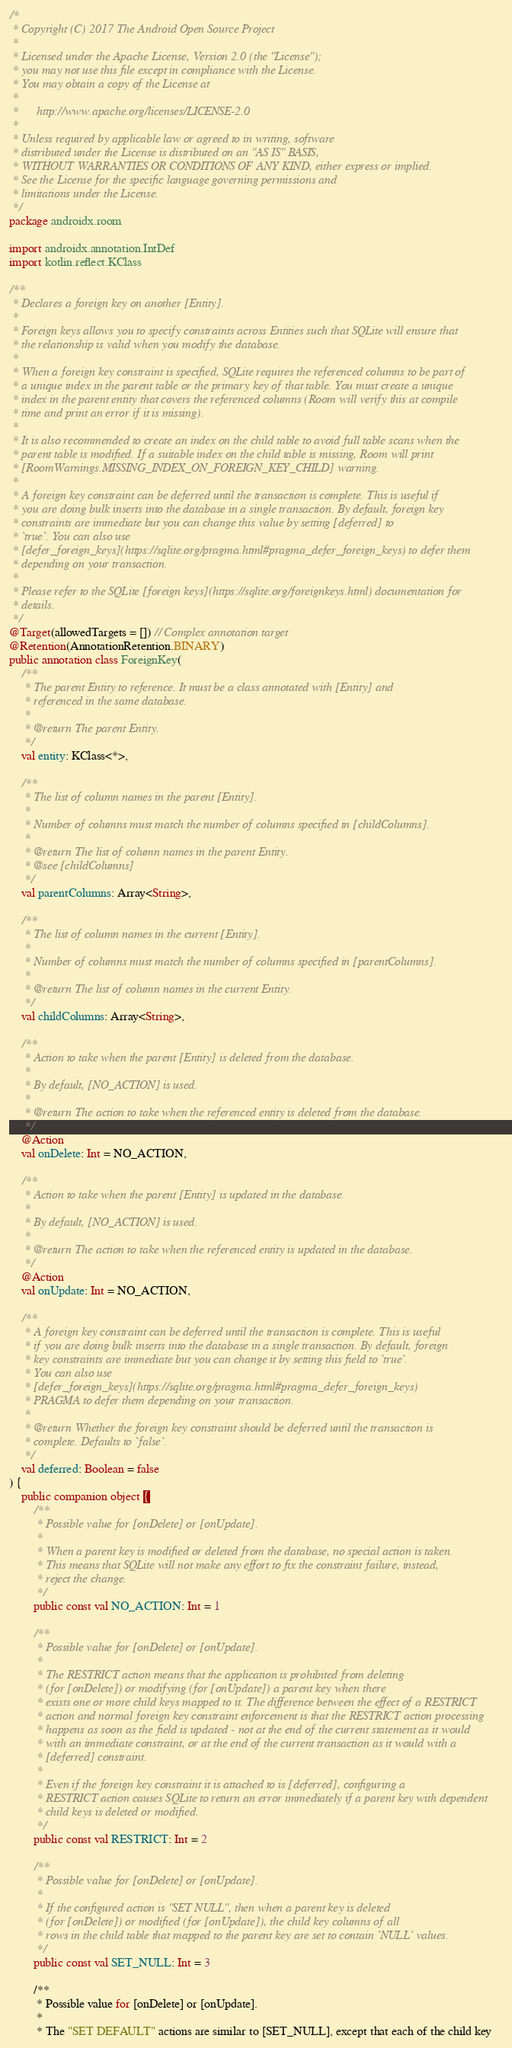Convert code to text. <code><loc_0><loc_0><loc_500><loc_500><_Kotlin_>/*
 * Copyright (C) 2017 The Android Open Source Project
 *
 * Licensed under the Apache License, Version 2.0 (the "License");
 * you may not use this file except in compliance with the License.
 * You may obtain a copy of the License at
 *
 *      http://www.apache.org/licenses/LICENSE-2.0
 *
 * Unless required by applicable law or agreed to in writing, software
 * distributed under the License is distributed on an "AS IS" BASIS,
 * WITHOUT WARRANTIES OR CONDITIONS OF ANY KIND, either express or implied.
 * See the License for the specific language governing permissions and
 * limitations under the License.
 */
package androidx.room

import androidx.annotation.IntDef
import kotlin.reflect.KClass

/**
 * Declares a foreign key on another [Entity].
 *
 * Foreign keys allows you to specify constraints across Entities such that SQLite will ensure that
 * the relationship is valid when you modify the database.
 *
 * When a foreign key constraint is specified, SQLite requires the referenced columns to be part of
 * a unique index in the parent table or the primary key of that table. You must create a unique
 * index in the parent entity that covers the referenced columns (Room will verify this at compile
 * time and print an error if it is missing).
 *
 * It is also recommended to create an index on the child table to avoid full table scans when the
 * parent table is modified. If a suitable index on the child table is missing, Room will print
 * [RoomWarnings.MISSING_INDEX_ON_FOREIGN_KEY_CHILD] warning.
 *
 * A foreign key constraint can be deferred until the transaction is complete. This is useful if
 * you are doing bulk inserts into the database in a single transaction. By default, foreign key
 * constraints are immediate but you can change this value by setting [deferred] to
 * `true`. You can also use
 * [defer_foreign_keys](https://sqlite.org/pragma.html#pragma_defer_foreign_keys) to defer them
 * depending on your transaction.
 *
 * Please refer to the SQLite [foreign keys](https://sqlite.org/foreignkeys.html) documentation for
 * details.
 */
@Target(allowedTargets = []) // Complex annotation target
@Retention(AnnotationRetention.BINARY)
public annotation class ForeignKey(
    /**
     * The parent Entity to reference. It must be a class annotated with [Entity] and
     * referenced in the same database.
     *
     * @return The parent Entity.
     */
    val entity: KClass<*>,

    /**
     * The list of column names in the parent [Entity].
     *
     * Number of columns must match the number of columns specified in [childColumns].
     *
     * @return The list of column names in the parent Entity.
     * @see [childColumns]
     */
    val parentColumns: Array<String>,

    /**
     * The list of column names in the current [Entity].
     *
     * Number of columns must match the number of columns specified in [parentColumns].
     *
     * @return The list of column names in the current Entity.
     */
    val childColumns: Array<String>,

    /**
     * Action to take when the parent [Entity] is deleted from the database.
     *
     * By default, [NO_ACTION] is used.
     *
     * @return The action to take when the referenced entity is deleted from the database.
     */
    @Action
    val onDelete: Int = NO_ACTION,

    /**
     * Action to take when the parent [Entity] is updated in the database.
     *
     * By default, [NO_ACTION] is used.
     *
     * @return The action to take when the referenced entity is updated in the database.
     */
    @Action
    val onUpdate: Int = NO_ACTION,

    /**
     * A foreign key constraint can be deferred until the transaction is complete. This is useful
     * if you are doing bulk inserts into the database in a single transaction. By default, foreign
     * key constraints are immediate but you can change it by setting this field to `true`.
     * You can also use
     * [defer_foreign_keys](https://sqlite.org/pragma.html#pragma_defer_foreign_keys)
     * PRAGMA to defer them depending on your transaction.
     *
     * @return Whether the foreign key constraint should be deferred until the transaction is
     * complete. Defaults to `false`.
     */
    val deferred: Boolean = false
) {
    public companion object {
        /**
         * Possible value for [onDelete] or [onUpdate].
         *
         * When a parent key is modified or deleted from the database, no special action is taken.
         * This means that SQLite will not make any effort to fix the constraint failure, instead,
         * reject the change.
         */
        public const val NO_ACTION: Int = 1

        /**
         * Possible value for [onDelete] or [onUpdate].
         *
         * The RESTRICT action means that the application is prohibited from deleting
         * (for [onDelete]) or modifying (for [onUpdate]) a parent key when there
         * exists one or more child keys mapped to it. The difference between the effect of a RESTRICT
         * action and normal foreign key constraint enforcement is that the RESTRICT action processing
         * happens as soon as the field is updated - not at the end of the current statement as it would
         * with an immediate constraint, or at the end of the current transaction as it would with a
         * [deferred] constraint.
         *
         * Even if the foreign key constraint it is attached to is [deferred], configuring a
         * RESTRICT action causes SQLite to return an error immediately if a parent key with dependent
         * child keys is deleted or modified.
         */
        public const val RESTRICT: Int = 2

        /**
         * Possible value for [onDelete] or [onUpdate].
         *
         * If the configured action is "SET NULL", then when a parent key is deleted
         * (for [onDelete]) or modified (for [onUpdate]), the child key columns of all
         * rows in the child table that mapped to the parent key are set to contain `NULL` values.
         */
        public const val SET_NULL: Int = 3

        /**
         * Possible value for [onDelete] or [onUpdate].
         *
         * The "SET DEFAULT" actions are similar to [SET_NULL], except that each of the child key</code> 